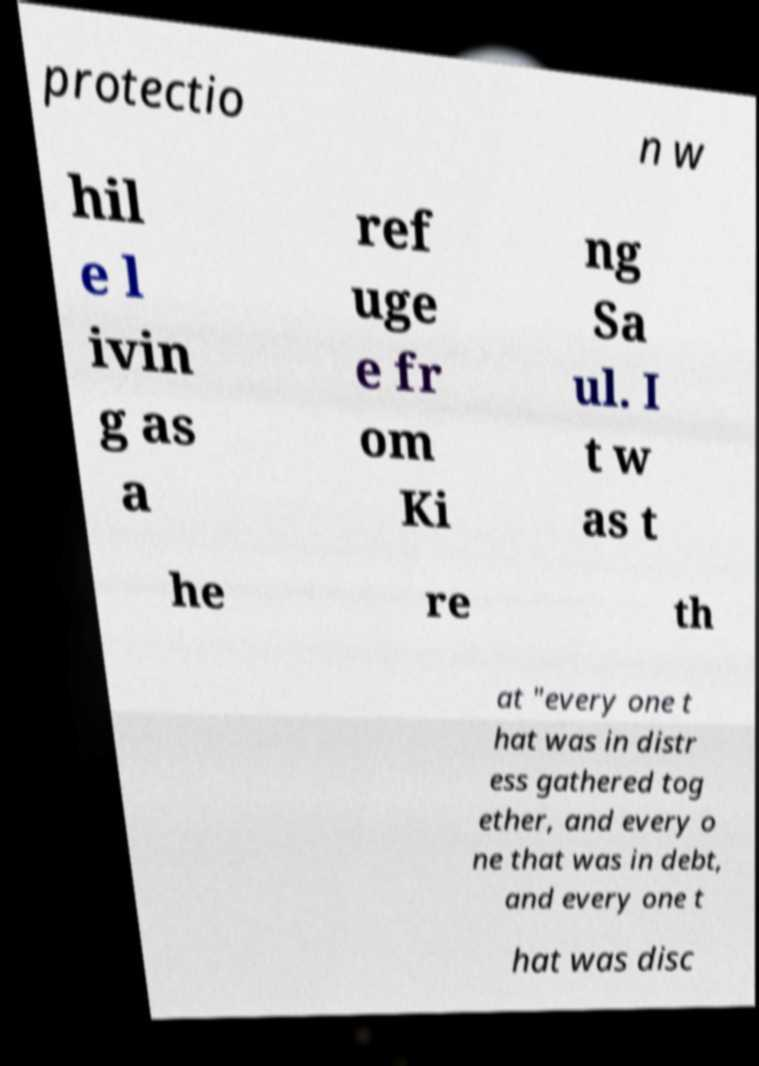I need the written content from this picture converted into text. Can you do that? protectio n w hil e l ivin g as a ref uge e fr om Ki ng Sa ul. I t w as t he re th at "every one t hat was in distr ess gathered tog ether, and every o ne that was in debt, and every one t hat was disc 